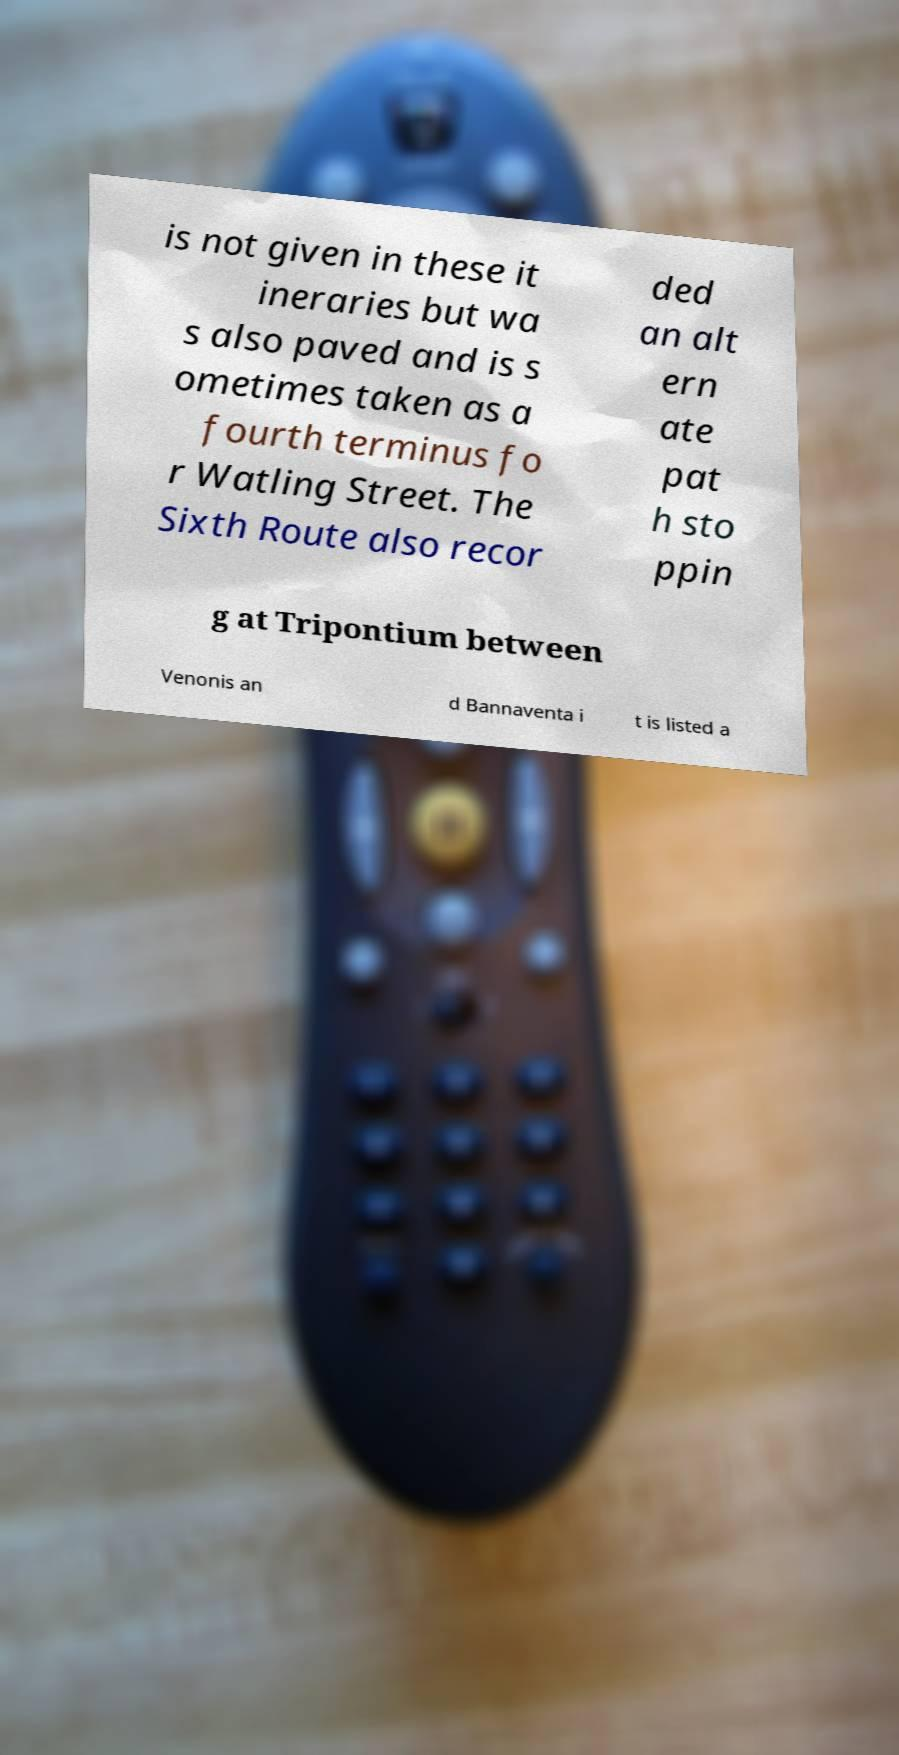Please identify and transcribe the text found in this image. is not given in these it ineraries but wa s also paved and is s ometimes taken as a fourth terminus fo r Watling Street. The Sixth Route also recor ded an alt ern ate pat h sto ppin g at Tripontium between Venonis an d Bannaventa i t is listed a 